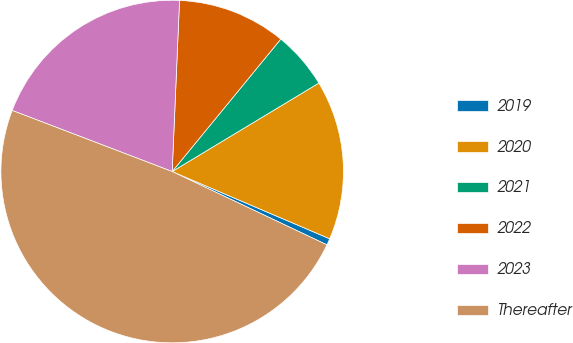<chart> <loc_0><loc_0><loc_500><loc_500><pie_chart><fcel>2019<fcel>2020<fcel>2021<fcel>2022<fcel>2023<fcel>Thereafter<nl><fcel>0.62%<fcel>15.06%<fcel>5.43%<fcel>10.25%<fcel>19.88%<fcel>48.77%<nl></chart> 